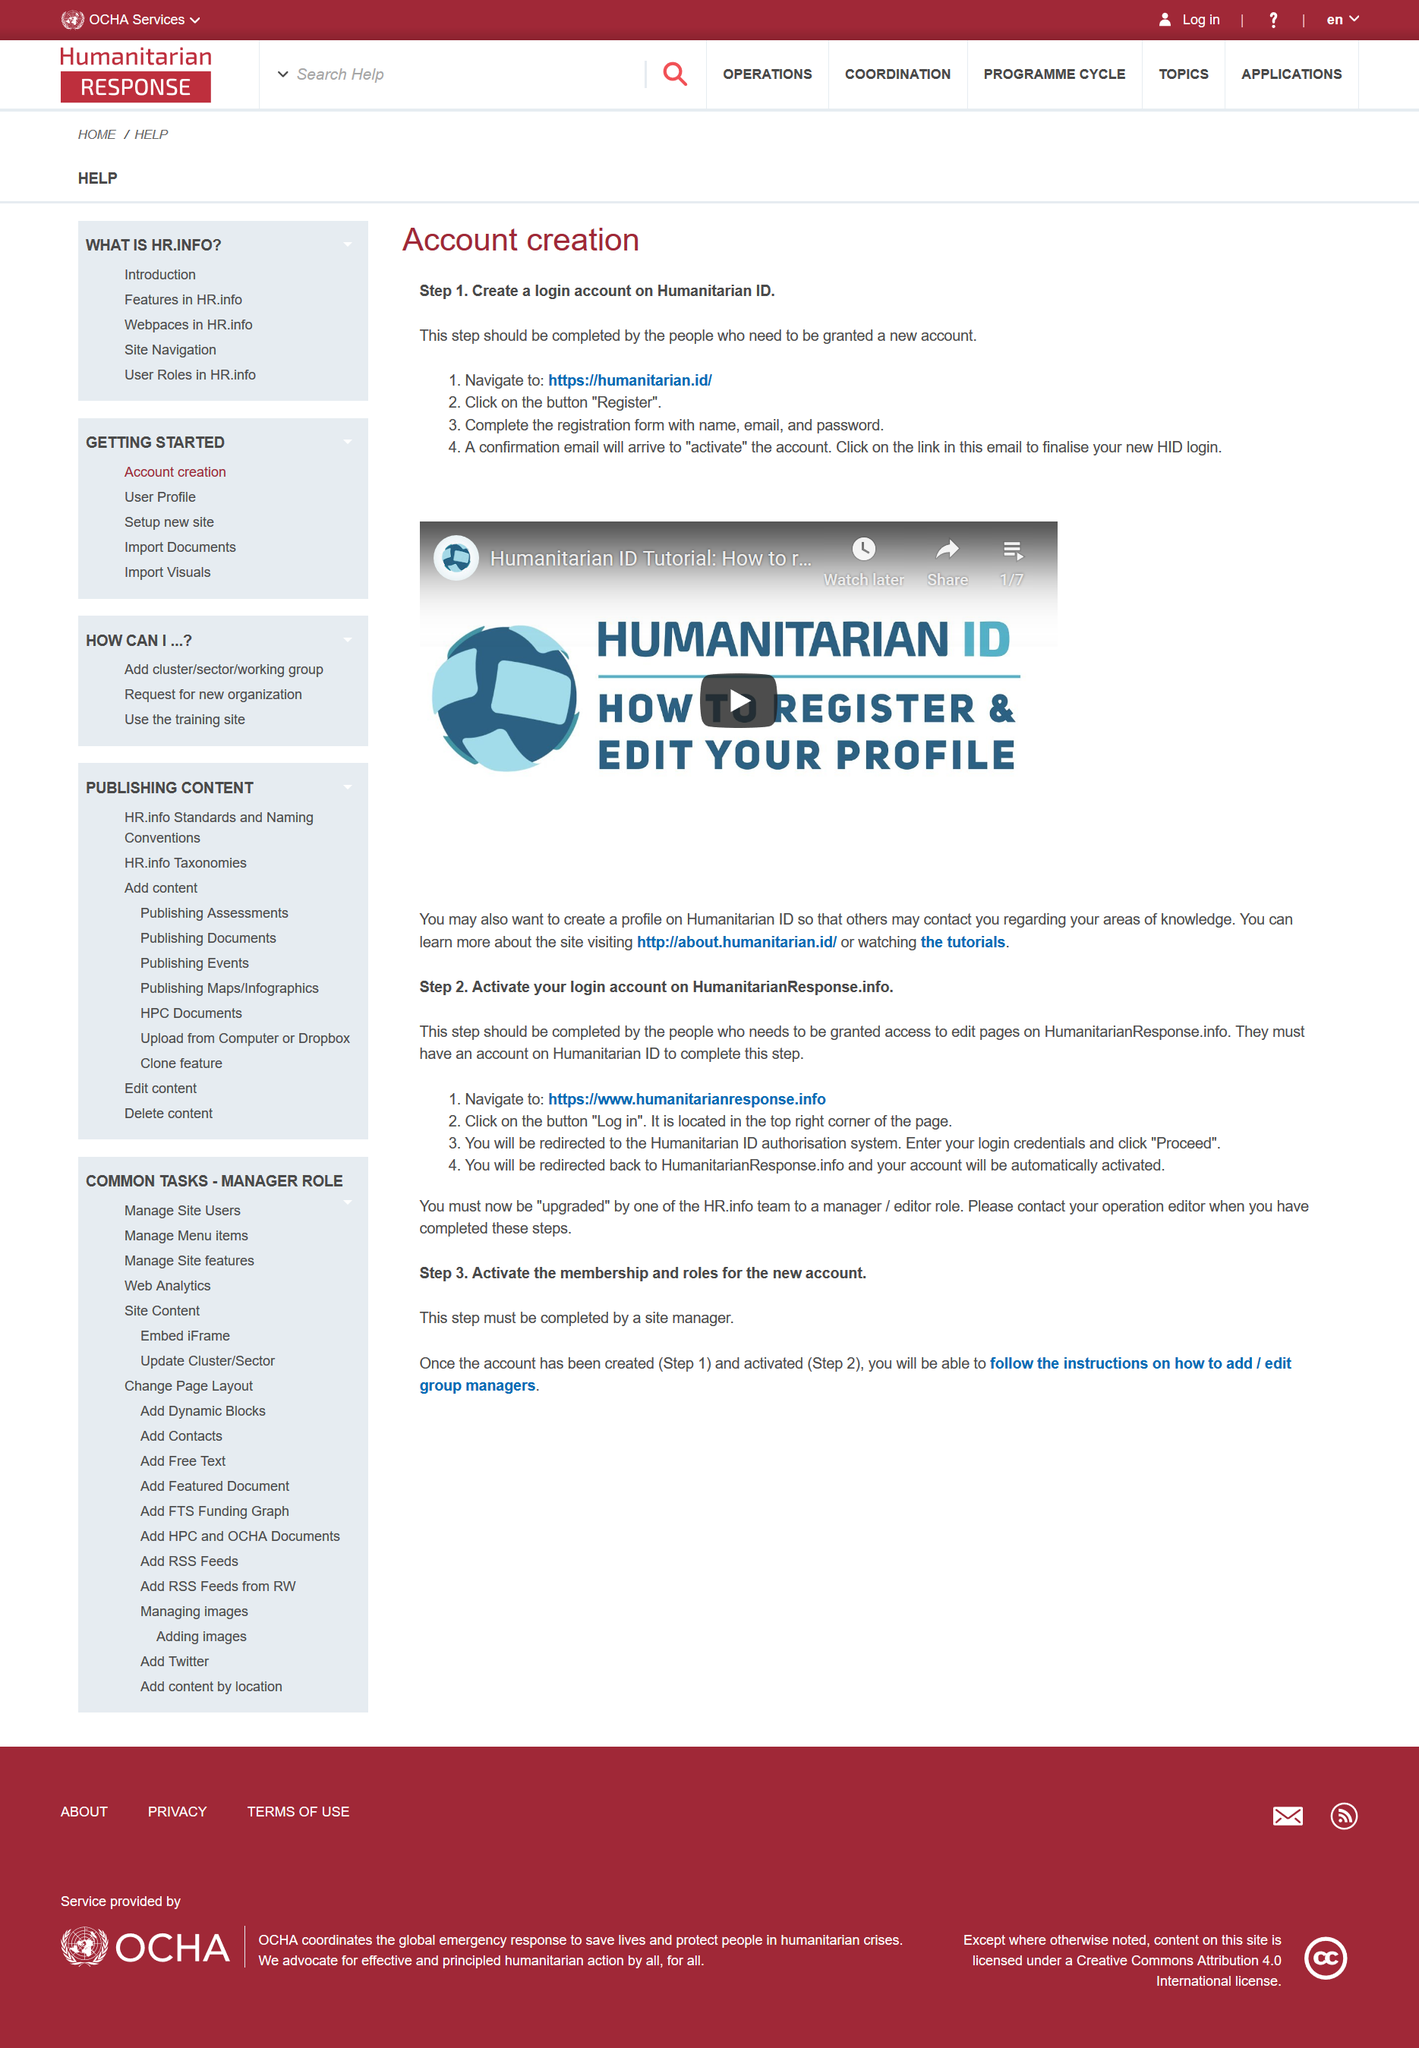Point out several critical features in this image. To activate a Humanitarian ID account, click on the link within the confirmation email that was sent to you. To activate a Humanitarian ID account, please click on the activation link contained within the confirmation email that was sent to you. A Humanitarian ID account can be activated by clicking on the link within the confirmation email that was sent to the user. 